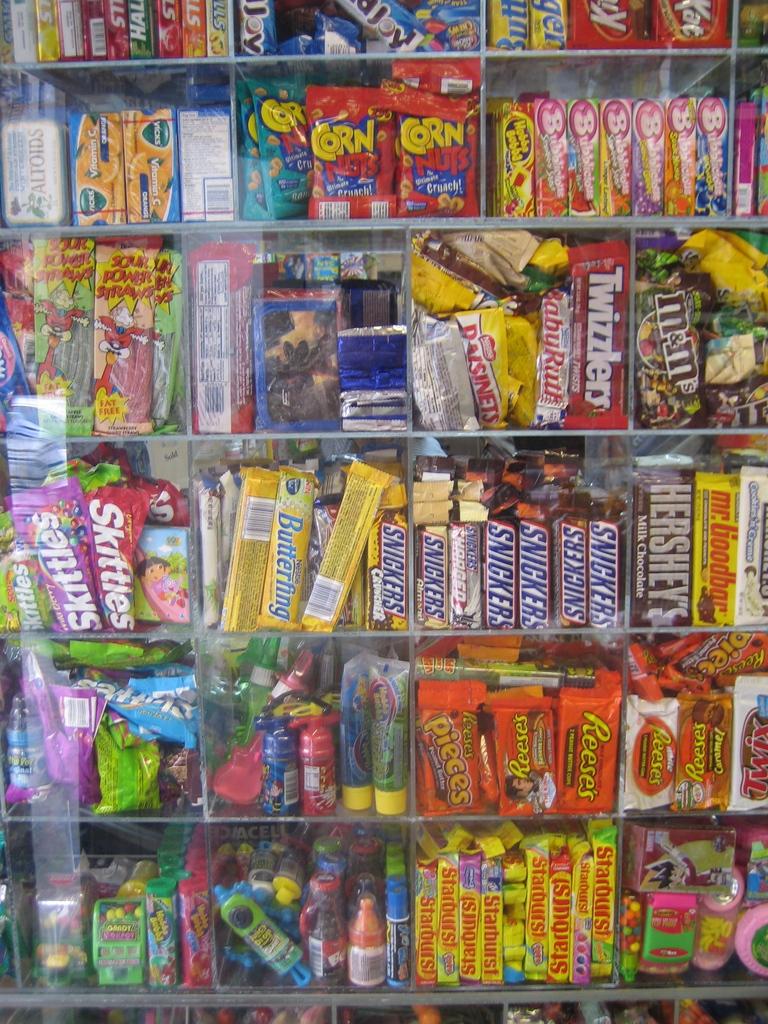What type of nuts are in the red bag at the top?
Ensure brevity in your answer.  Corn. 